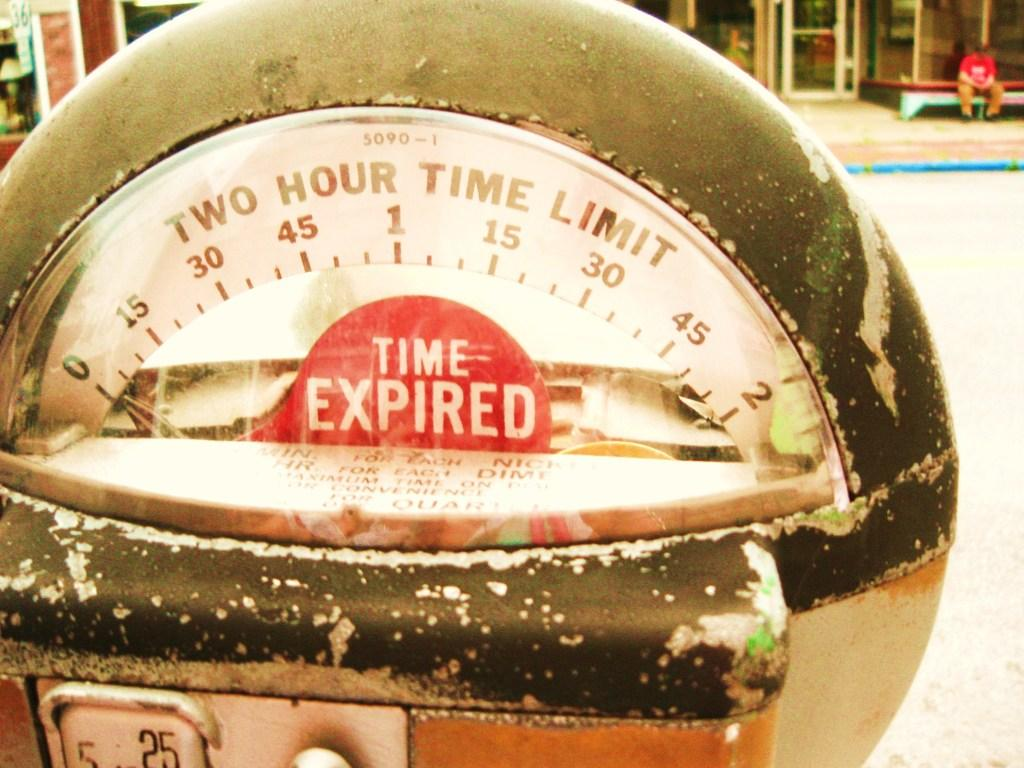<image>
Provide a brief description of the given image. A closeup of a parking meter shows that the time has expired. 